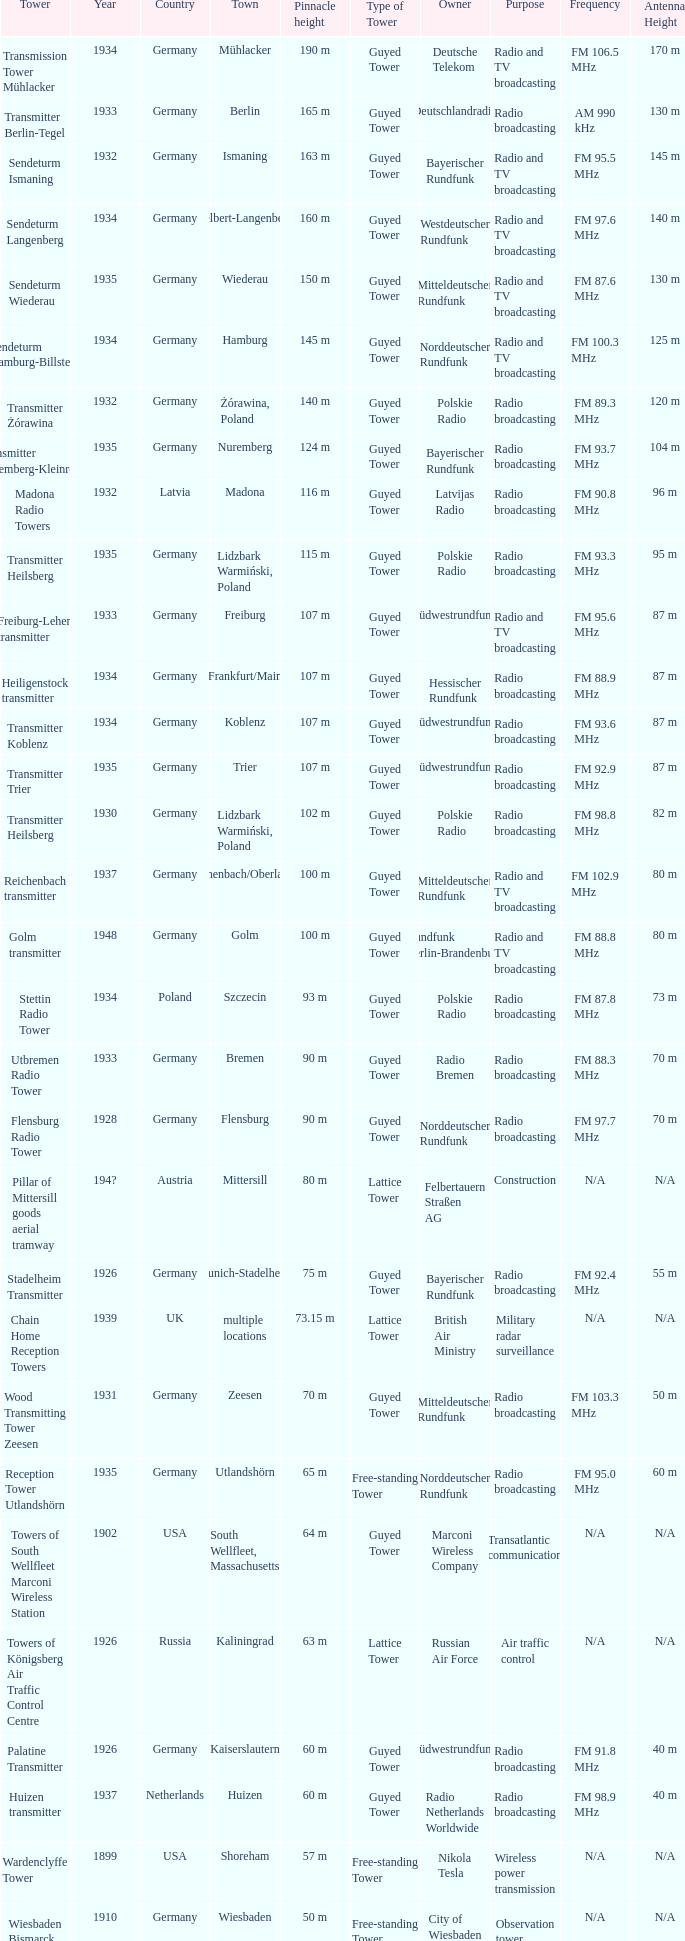Which country had a tower destroyed in 1899? USA. 